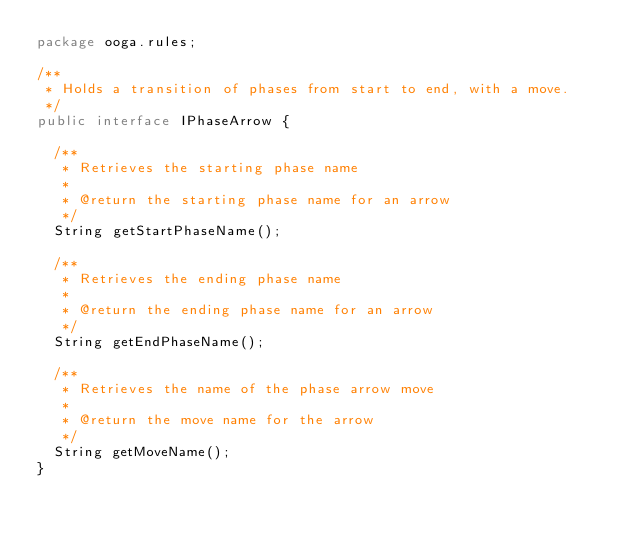<code> <loc_0><loc_0><loc_500><loc_500><_Java_>package ooga.rules;

/**
 * Holds a transition of phases from start to end, with a move.
 */
public interface IPhaseArrow {

  /**
   * Retrieves the starting phase name
   *
   * @return the starting phase name for an arrow
   */
  String getStartPhaseName();

  /**
   * Retrieves the ending phase name
   *
   * @return the ending phase name for an arrow
   */
  String getEndPhaseName();

  /**
   * Retrieves the name of the phase arrow move
   *
   * @return the move name for the arrow
   */
  String getMoveName();
}
</code> 